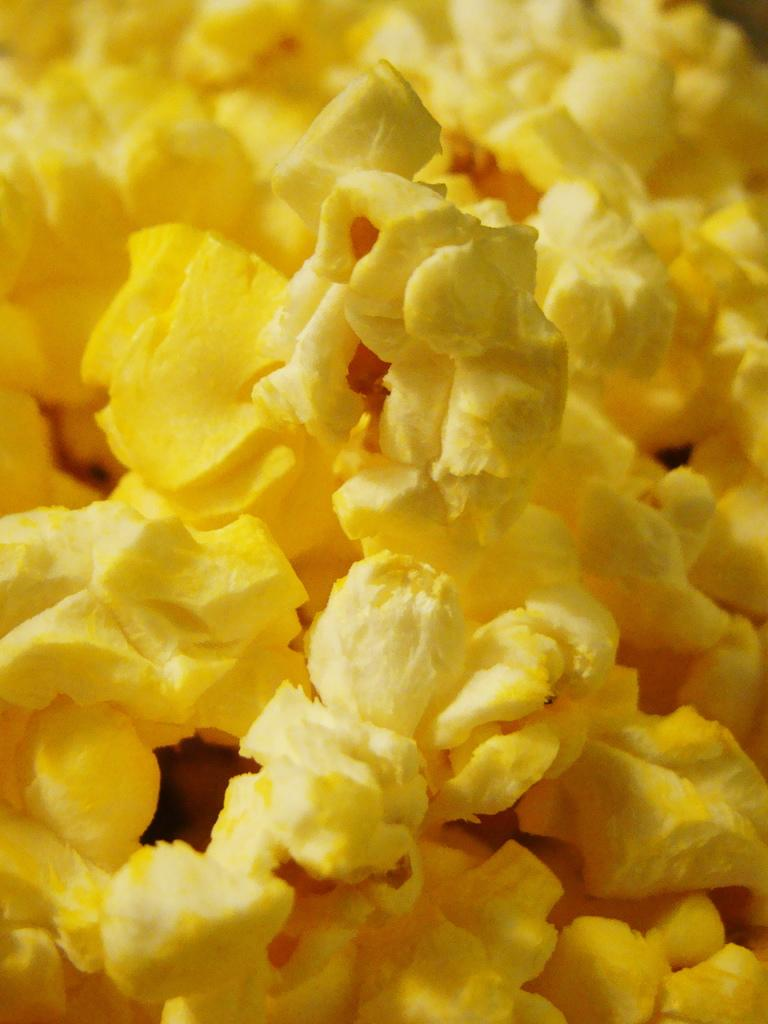What type of food is visible in the image? There are popcorns in the image. Can you see any soda cans near the popcorns in the image? There is no mention of soda cans or any other items besides popcorns in the image. 